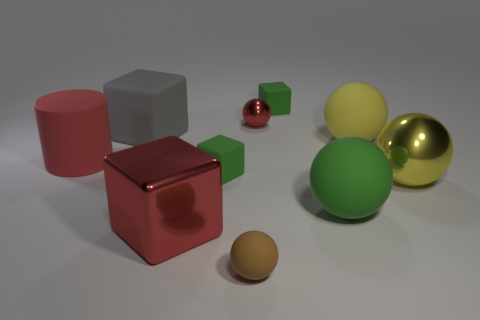Subtract all red balls. How many balls are left? 4 Subtract all red spheres. How many spheres are left? 4 Subtract all blue balls. Subtract all gray cylinders. How many balls are left? 5 Subtract all cylinders. How many objects are left? 9 Subtract all red spheres. Subtract all large green objects. How many objects are left? 8 Add 4 large yellow balls. How many large yellow balls are left? 6 Add 8 tiny green shiny objects. How many tiny green shiny objects exist? 8 Subtract 2 green blocks. How many objects are left? 8 